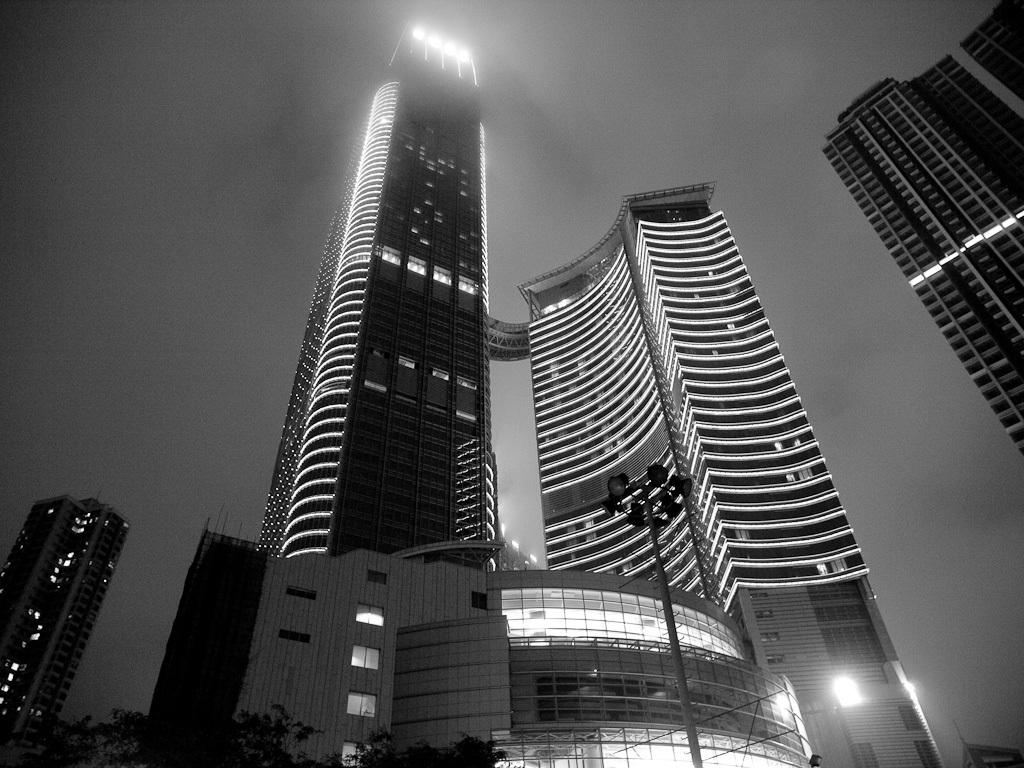What type of natural elements can be seen in the image? There are trees in the image. What type of artificial elements can be seen in the image? There are lights on poles and many buildings in the image. What is visible in the background of the image? The sky is visible in the background of the image. What is the color scheme of the image? The image is black and white. How many cobwebs can be seen on the buildings in the image? There are no cobwebs visible in the image; it is a black and white image with a focus on trees, lights, buildings, and the sky. 